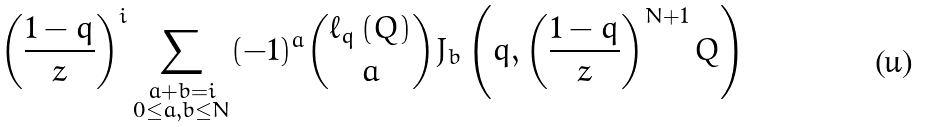Convert formula to latex. <formula><loc_0><loc_0><loc_500><loc_500>\left ( \frac { 1 - q } { z } \right ) ^ { i } \sum _ { \substack { a + b = i \\ 0 \leq a , b \leq N } } ( - 1 ) ^ { a } \binom { \ell _ { q } \left ( Q \right ) } { a } J _ { b } \left ( q , \left ( \frac { 1 - q } { z } \right ) ^ { N + 1 } Q \right )</formula> 